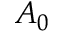Convert formula to latex. <formula><loc_0><loc_0><loc_500><loc_500>A _ { 0 }</formula> 